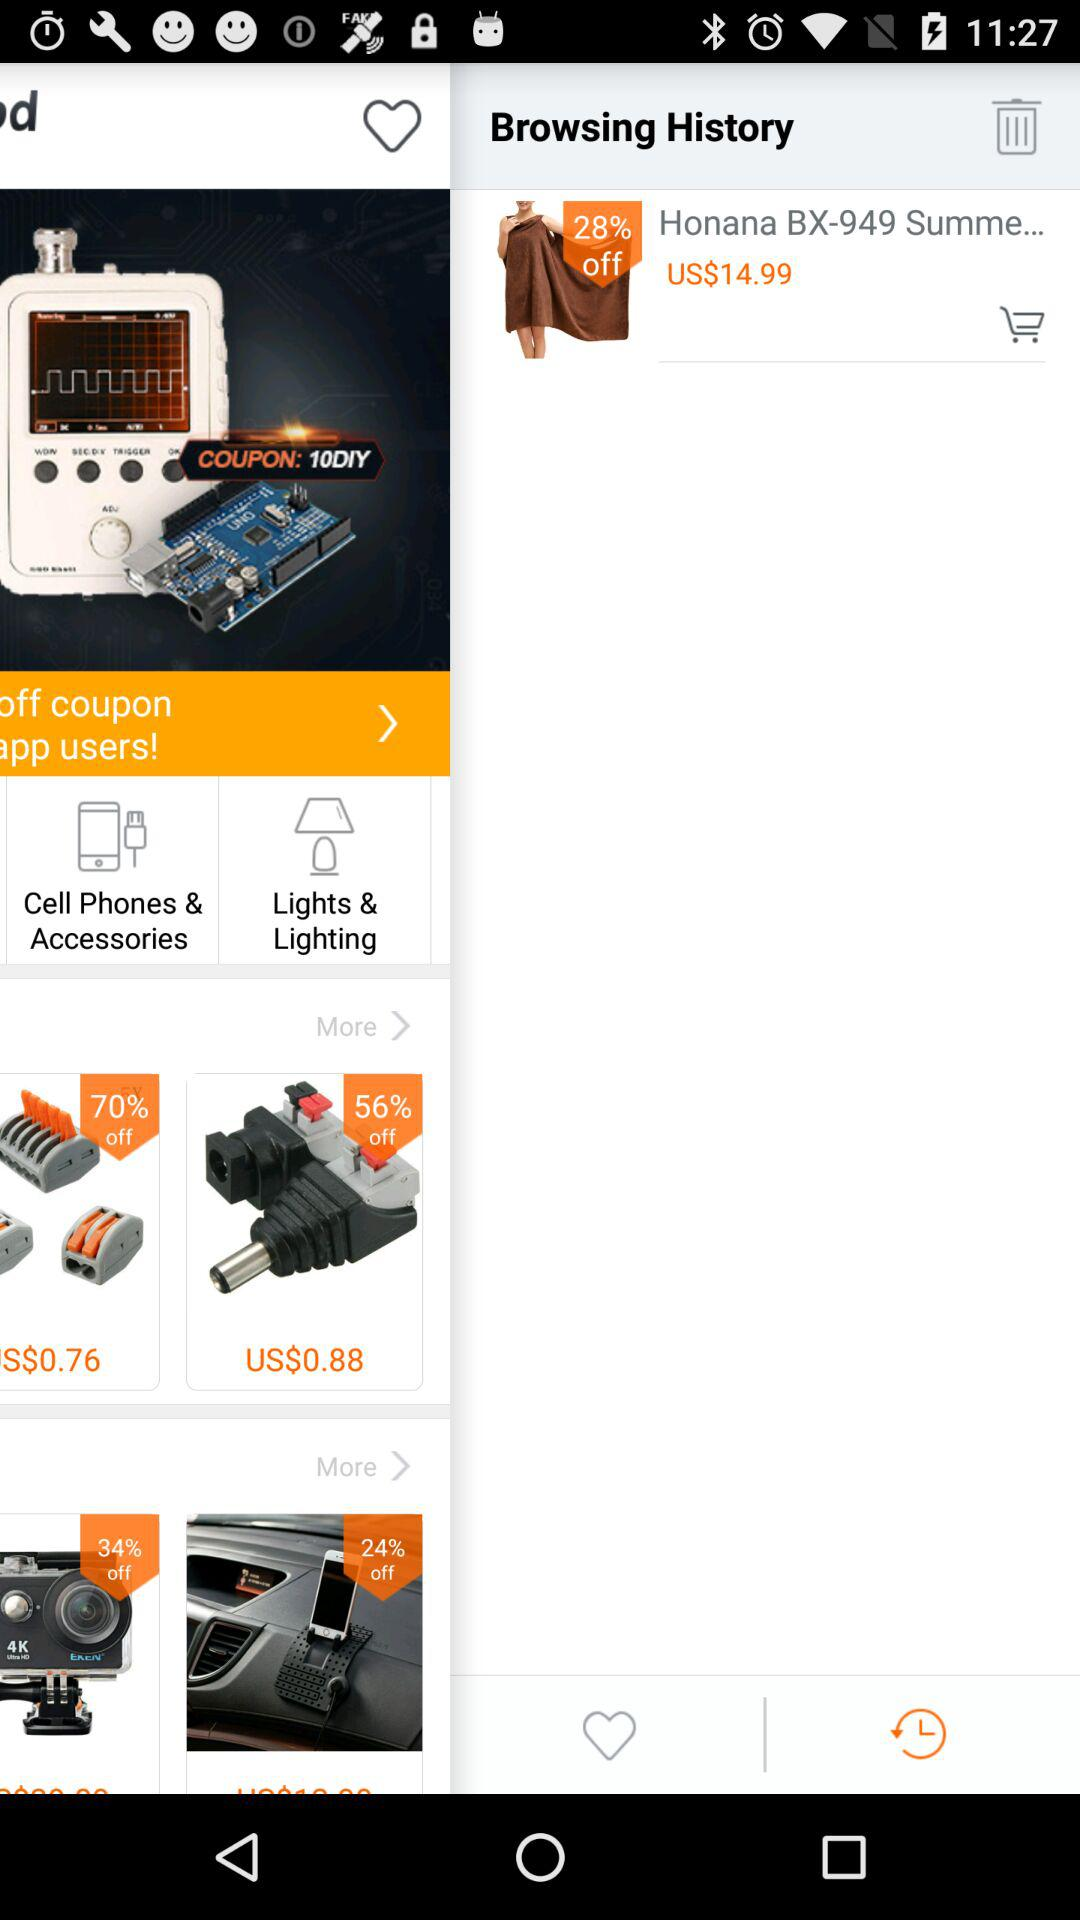What is the price of honana? The price of honana is US$14.99. 